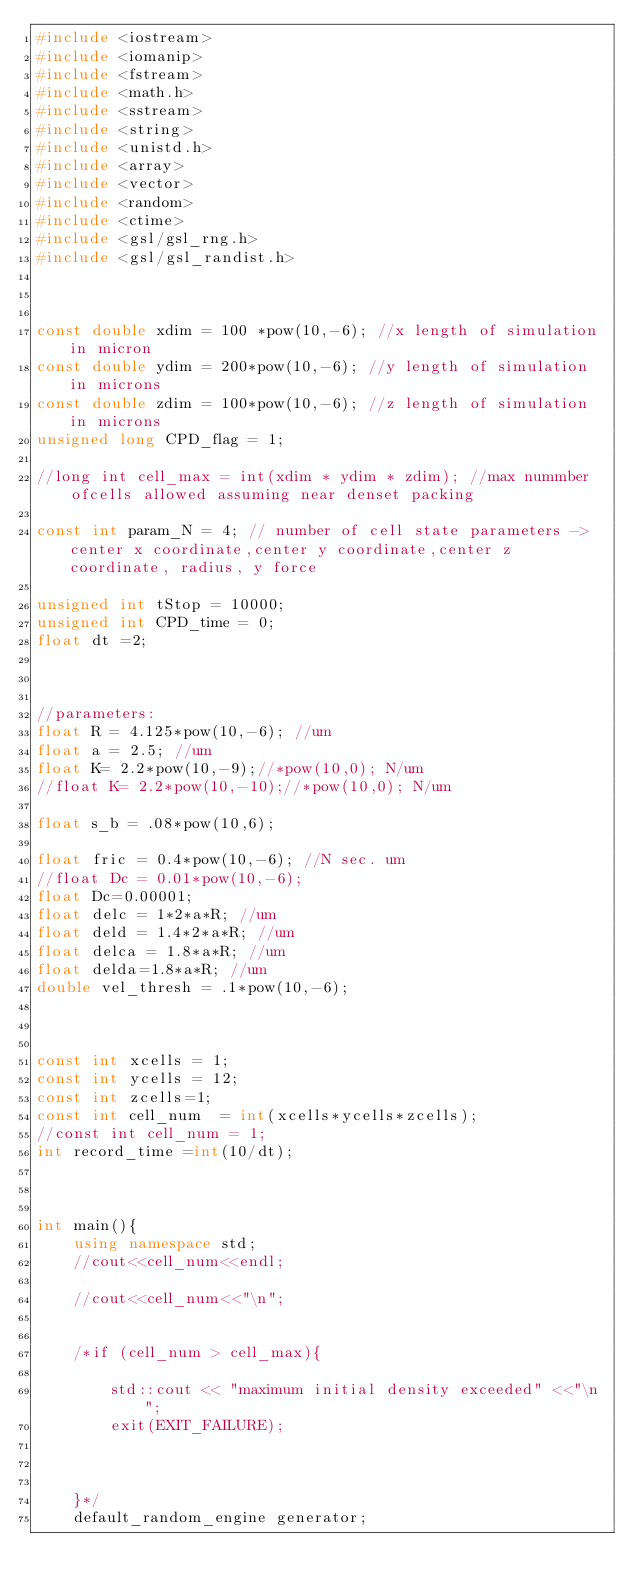<code> <loc_0><loc_0><loc_500><loc_500><_C++_>#include <iostream>
#include <iomanip>
#include <fstream>
#include <math.h>
#include <sstream>
#include <string>
#include <unistd.h>
#include <array>
#include <vector>
#include <random>
#include <ctime>
#include <gsl/gsl_rng.h>
#include <gsl/gsl_randist.h>



const double xdim = 100 *pow(10,-6); //x length of simulation in micron
const double ydim = 200*pow(10,-6); //y length of simulation in microns
const double zdim = 100*pow(10,-6); //z length of simulation in microns
unsigned long CPD_flag = 1;

//long int cell_max = int(xdim * ydim * zdim); //max nummber ofcells allowed assuming near denset packing

const int param_N = 4; // number of cell state parameters -> center x coordinate,center y coordinate,center z coordinate, radius, y force

unsigned int tStop = 10000;
unsigned int CPD_time = 0;
float dt =2;



//parameters:
float R = 4.125*pow(10,-6); //um
float a = 2.5; //um
float K= 2.2*pow(10,-9);//*pow(10,0); N/um
//float K= 2.2*pow(10,-10);//*pow(10,0); N/um

float s_b = .08*pow(10,6);

float fric = 0.4*pow(10,-6); //N sec. um
//float Dc = 0.01*pow(10,-6);
float Dc=0.00001;
float delc = 1*2*a*R; //um
float deld = 1.4*2*a*R; //um
float delca = 1.8*a*R; //um
float delda=1.8*a*R; //um
double vel_thresh = .1*pow(10,-6);



const int xcells = 1;
const int ycells = 12;
const int zcells=1;
const int cell_num  = int(xcells*ycells*zcells);
//const int cell_num = 1;
int record_time =int(10/dt);



int main(){
    using namespace std;
    //cout<<cell_num<<endl;

    //cout<<cell_num<<"\n";


    /*if (cell_num > cell_max){

        std::cout << "maximum initial density exceeded" <<"\n";
        exit(EXIT_FAILURE);



    }*/
    default_random_engine generator;</code> 